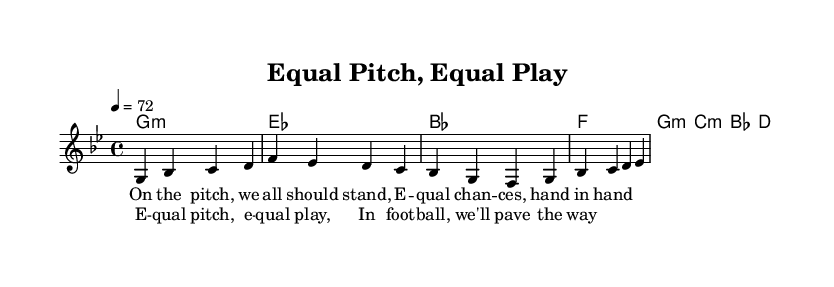What is the key signature of this music? The key signature is G minor, indicated by the presence of two flats (B flat and E flat) after the clef on the staff.
Answer: G minor What is the time signature of this music? The time signature shown on the staff is 4/4, which means there are four beats in each measure and each quarter note gets one beat.
Answer: 4/4 What is the tempo marking for the music? The tempo marking is 4 = 72, which indicates that each quarter note should be played at a speed of 72 beats per minute.
Answer: 72 How many measures are there in the melody section? The melody section consists of four measures, as indicated by the grouping of notes and the end of each measure separated by vertical lines.
Answer: 4 What is the main theme of the lyrics? The main theme of the lyrics addresses equality in sports, focusing on the idea of everyone standing together for equal chances in football.
Answer: Equality Which chord is played in the first measure? The chord played in the first measure is G minor, as noted in the chord names section at the beginning of the score.
Answer: G minor What is the repeated phrase in the chorus? The repeated phrase in the chorus is "Equal pitch, equal play," emphasizing the call for equal treatment and opportunity in football.
Answer: Equal pitch, equal play 